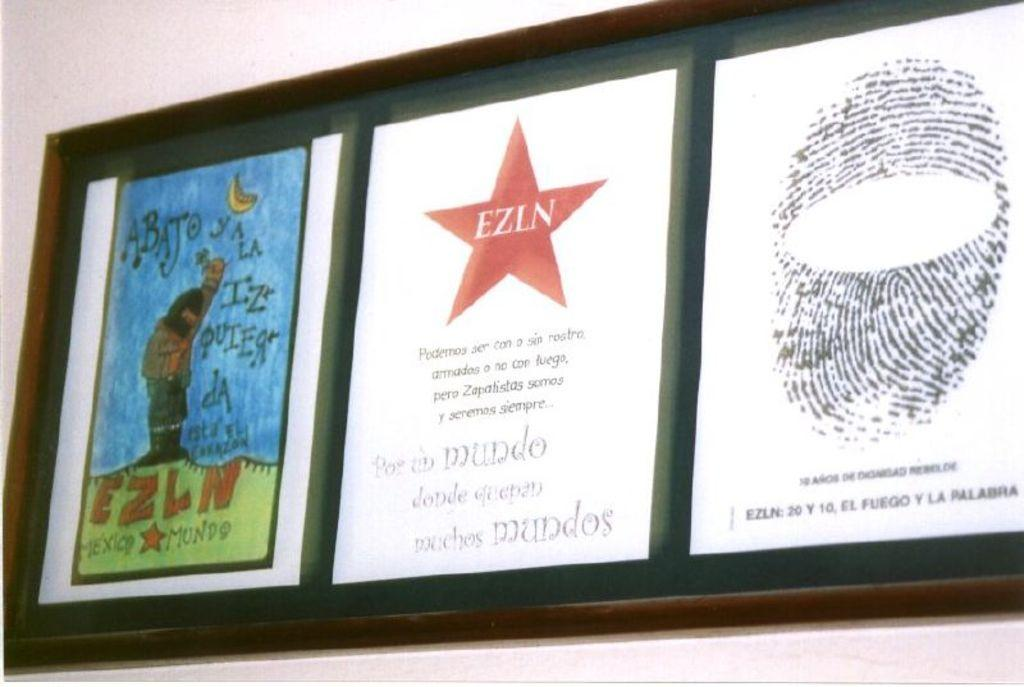<image>
Create a compact narrative representing the image presented. The middle picture has a red star with the letters EZLN in the middle 